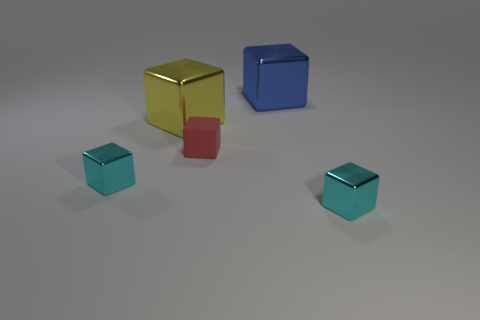What number of other blocks have the same size as the yellow block?
Make the answer very short. 1. What is the blue block made of?
Provide a succinct answer. Metal. Are there more large yellow matte objects than small matte objects?
Provide a succinct answer. No. Does the yellow metallic object have the same shape as the small red object?
Keep it short and to the point. Yes. Is there any other thing that is the same shape as the small red matte thing?
Your answer should be compact. Yes. Does the small block right of the blue shiny cube have the same color as the small thing left of the yellow metal cube?
Provide a succinct answer. Yes. Is the number of cyan metal cubes that are on the left side of the small matte block less than the number of tiny cyan cubes right of the blue metal object?
Give a very brief answer. No. The object behind the big yellow shiny cube has what shape?
Provide a succinct answer. Cube. What number of other objects are the same material as the tiny red cube?
Offer a terse response. 0. Do the yellow metal thing and the red matte thing right of the large yellow thing have the same shape?
Offer a terse response. Yes. 